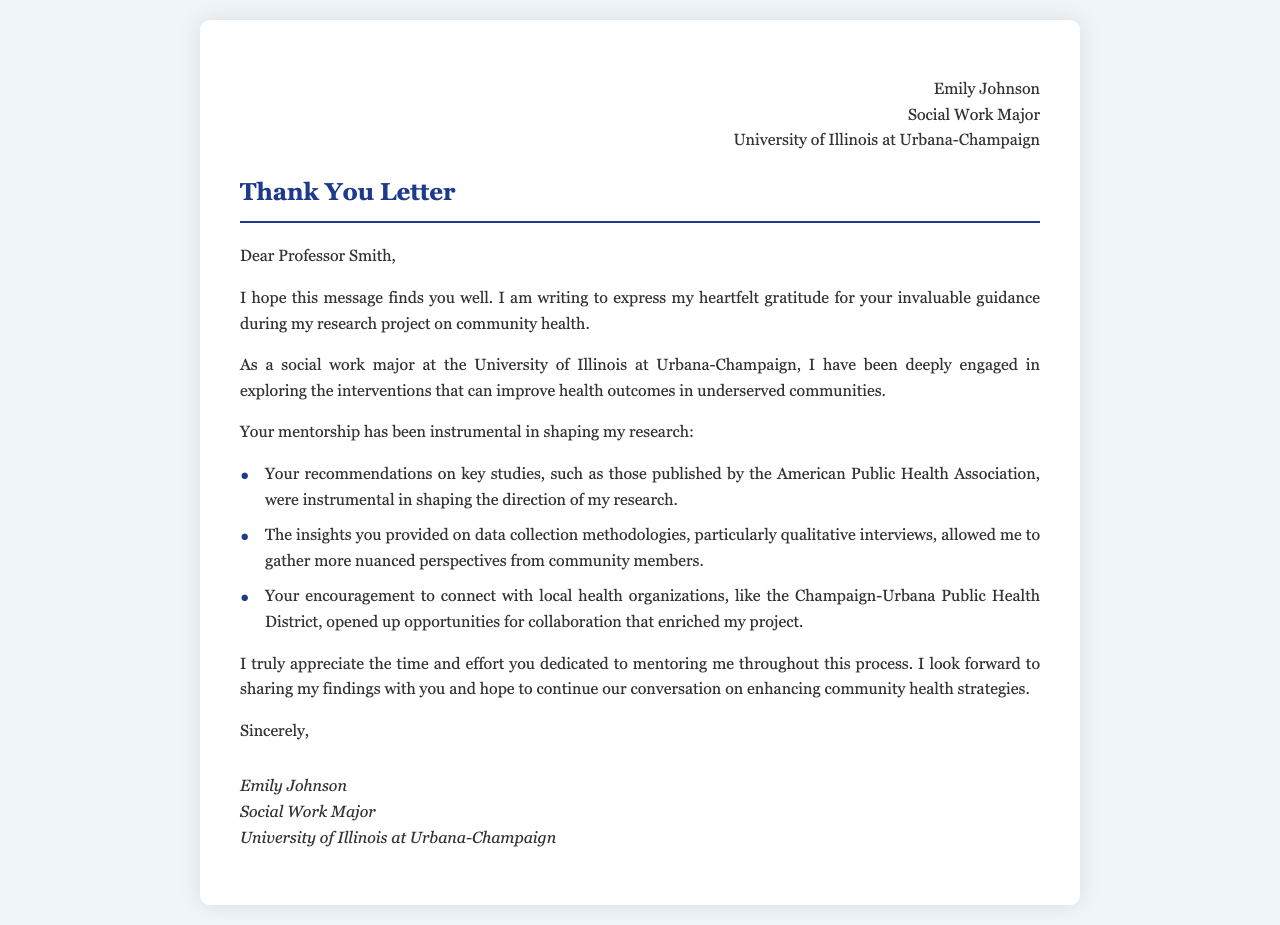What is the sender's name? The sender's name is mentioned at the beginning of the letter.
Answer: Emily Johnson What is the professor's name? The professor's name is addressed in the salutation of the letter.
Answer: Professor Smith What is the sender's major? The sender's major is listed in the header of the letter.
Answer: Social Work Major What university is the sender attending? The university where the sender is studying is mentioned in the header.
Answer: University of Illinois at Urbana-Champaign How many key studies were mentioned in the letter? The letter lists specific contributions, which include three key points about the research mentorship.
Answer: Three What local health organization was referenced? The letter mentions a local health organization as part of the sender's research collaboration.
Answer: Champaign-Urbana Public Health District What type of research project is being discussed? The type of project being referenced in the letter focuses on health-related interventions.
Answer: Community health What kind of methodologies did the professor provide insights about? The professor gave guidance on specific methods used in the research, which is highlighted in the document.
Answer: Qualitative interviews What is the closing phrase of the letter? The letter concludes with a formal sign-off that is typical for professional correspondence.
Answer: Sincerely 